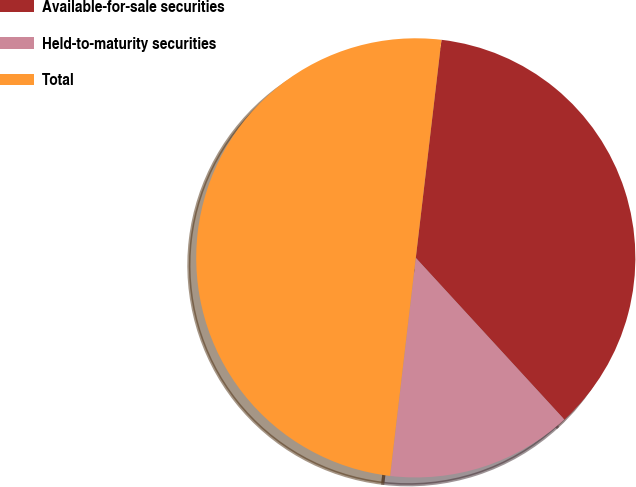<chart> <loc_0><loc_0><loc_500><loc_500><pie_chart><fcel>Available-for-sale securities<fcel>Held-to-maturity securities<fcel>Total<nl><fcel>36.31%<fcel>13.69%<fcel>50.0%<nl></chart> 